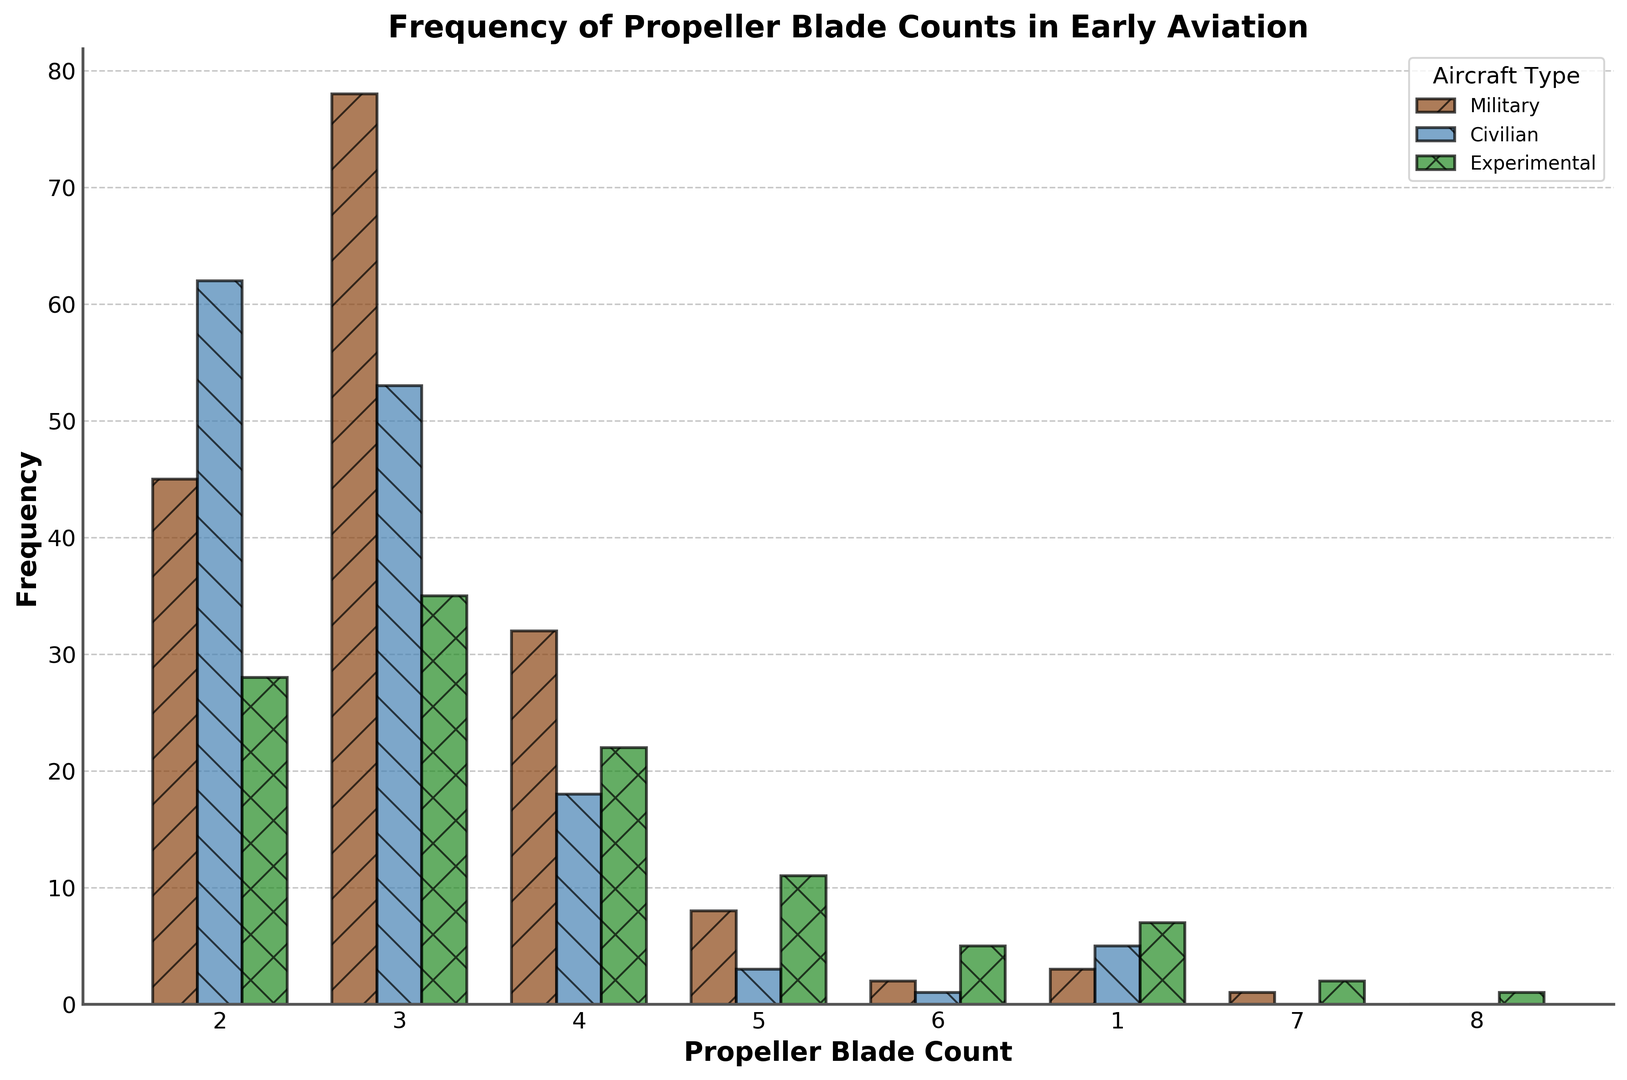How many propeller blade counts are most common among military aircraft? Identify the bar with the highest frequency in the Military category. The highest frequency is for 3-blade propellers with a frequency of 78.
Answer: 3-blade Which aircraft type has more 4-blade propellers, civilian or experimental? Compare the 4-blade propeller frequencies between Civilian (18) and Experimental (22). Experimental is higher.
Answer: Experimental What is the total number of all aircraft with 2-blade propellers? Add the frequencies for 2-blade propellers across all types: Military (45) + Civilian (62) + Experimental (28) = 135.
Answer: 135 Are 5-blade propellers more common in military or civilian aircraft? Compare the frequencies of 5-blade propellers between Military (8) and Civilian (3). Military is higher.
Answer: Military Which propeller blade count is unique to Experimental aircraft? Identify which counts appear exclusively under Experimental: 8-blade propellers appear only under Experimental.
Answer: 8-blade What is the total frequency of 6-blade propellers across all aircraft types? Sum the frequencies of 6-blade propellers for each type: Military (2) + Civilian (1) + Experimental (5) = 8.
Answer: 8 Which type of aircraft has the least variety in propeller blade counts? Identify the counts present under each aircraft type and see which list has the fewest unique counts. The Civilian type has blades ranging from 1 to 6, which is fewer compared to Military and Experimental.
Answer: Civilian What proportion of experimental aircraft have 3-blade propellers? Divide the frequency of 3-blade propellers in Experimental (35) by the total frequency of Experimental blades: 35 / (28+35+22+11+5+7+2+1) = 35 / 111 ≈ 31.53%.
Answer: 31.53% Which propeller blade count is equally common in both military and experimental kinds of aircraft? Identify any propeller counts with the same frequency in both categories. There are no equal frequencies between Military and Experimental blade counts.
Answer: None 